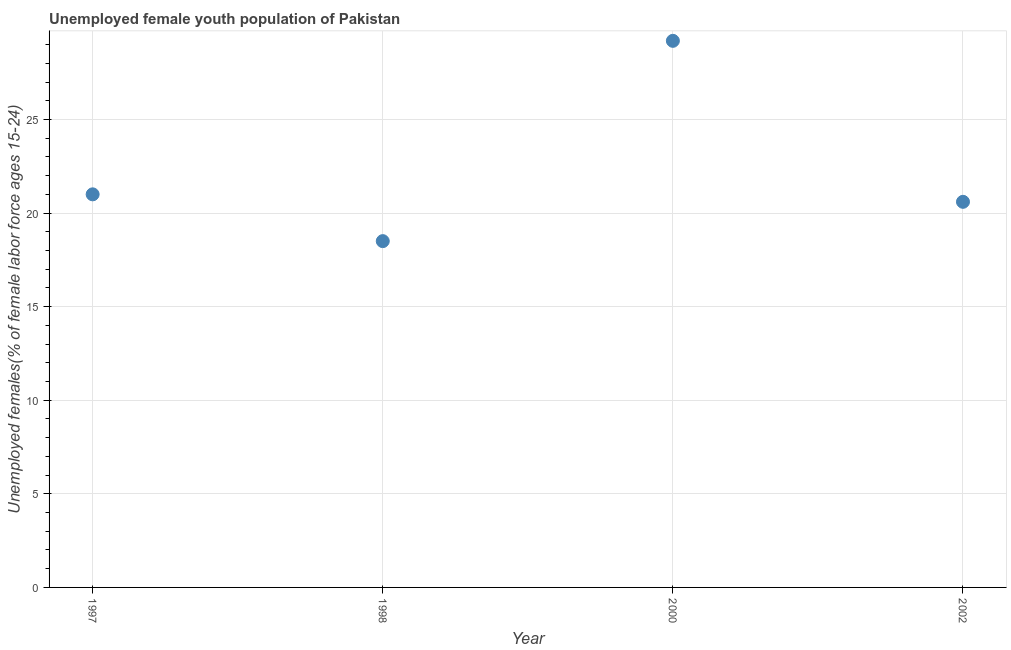What is the unemployed female youth in 2002?
Ensure brevity in your answer.  20.6. Across all years, what is the maximum unemployed female youth?
Provide a succinct answer. 29.2. In which year was the unemployed female youth maximum?
Your response must be concise. 2000. What is the sum of the unemployed female youth?
Provide a short and direct response. 89.3. What is the difference between the unemployed female youth in 1997 and 2002?
Provide a short and direct response. 0.4. What is the average unemployed female youth per year?
Offer a very short reply. 22.33. What is the median unemployed female youth?
Keep it short and to the point. 20.8. Do a majority of the years between 1998 and 2002 (inclusive) have unemployed female youth greater than 4 %?
Offer a very short reply. Yes. What is the ratio of the unemployed female youth in 2000 to that in 2002?
Provide a short and direct response. 1.42. Is the difference between the unemployed female youth in 1997 and 2000 greater than the difference between any two years?
Keep it short and to the point. No. What is the difference between the highest and the second highest unemployed female youth?
Your answer should be very brief. 8.2. Is the sum of the unemployed female youth in 1997 and 2000 greater than the maximum unemployed female youth across all years?
Offer a terse response. Yes. What is the difference between the highest and the lowest unemployed female youth?
Provide a succinct answer. 10.7. Does the unemployed female youth monotonically increase over the years?
Provide a short and direct response. No. How many dotlines are there?
Provide a succinct answer. 1. How many years are there in the graph?
Provide a succinct answer. 4. What is the difference between two consecutive major ticks on the Y-axis?
Provide a succinct answer. 5. Are the values on the major ticks of Y-axis written in scientific E-notation?
Offer a very short reply. No. Does the graph contain grids?
Ensure brevity in your answer.  Yes. What is the title of the graph?
Provide a succinct answer. Unemployed female youth population of Pakistan. What is the label or title of the Y-axis?
Provide a succinct answer. Unemployed females(% of female labor force ages 15-24). What is the Unemployed females(% of female labor force ages 15-24) in 1998?
Offer a very short reply. 18.5. What is the Unemployed females(% of female labor force ages 15-24) in 2000?
Provide a succinct answer. 29.2. What is the Unemployed females(% of female labor force ages 15-24) in 2002?
Offer a terse response. 20.6. What is the difference between the Unemployed females(% of female labor force ages 15-24) in 1998 and 2000?
Provide a succinct answer. -10.7. What is the difference between the Unemployed females(% of female labor force ages 15-24) in 1998 and 2002?
Your answer should be compact. -2.1. What is the difference between the Unemployed females(% of female labor force ages 15-24) in 2000 and 2002?
Provide a succinct answer. 8.6. What is the ratio of the Unemployed females(% of female labor force ages 15-24) in 1997 to that in 1998?
Provide a succinct answer. 1.14. What is the ratio of the Unemployed females(% of female labor force ages 15-24) in 1997 to that in 2000?
Your answer should be compact. 0.72. What is the ratio of the Unemployed females(% of female labor force ages 15-24) in 1997 to that in 2002?
Offer a terse response. 1.02. What is the ratio of the Unemployed females(% of female labor force ages 15-24) in 1998 to that in 2000?
Provide a succinct answer. 0.63. What is the ratio of the Unemployed females(% of female labor force ages 15-24) in 1998 to that in 2002?
Your answer should be compact. 0.9. What is the ratio of the Unemployed females(% of female labor force ages 15-24) in 2000 to that in 2002?
Your answer should be compact. 1.42. 